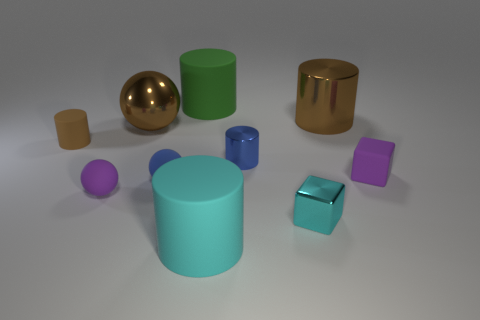Subtract all red blocks. How many brown cylinders are left? 2 Subtract all brown cylinders. How many cylinders are left? 3 Subtract all matte balls. How many balls are left? 1 Subtract 1 balls. How many balls are left? 2 Subtract all spheres. How many objects are left? 7 Subtract all yellow cylinders. Subtract all green cubes. How many cylinders are left? 5 Subtract all small brown matte objects. Subtract all large cyan objects. How many objects are left? 8 Add 9 blue spheres. How many blue spheres are left? 10 Add 5 green rubber things. How many green rubber things exist? 6 Subtract 0 gray cylinders. How many objects are left? 10 